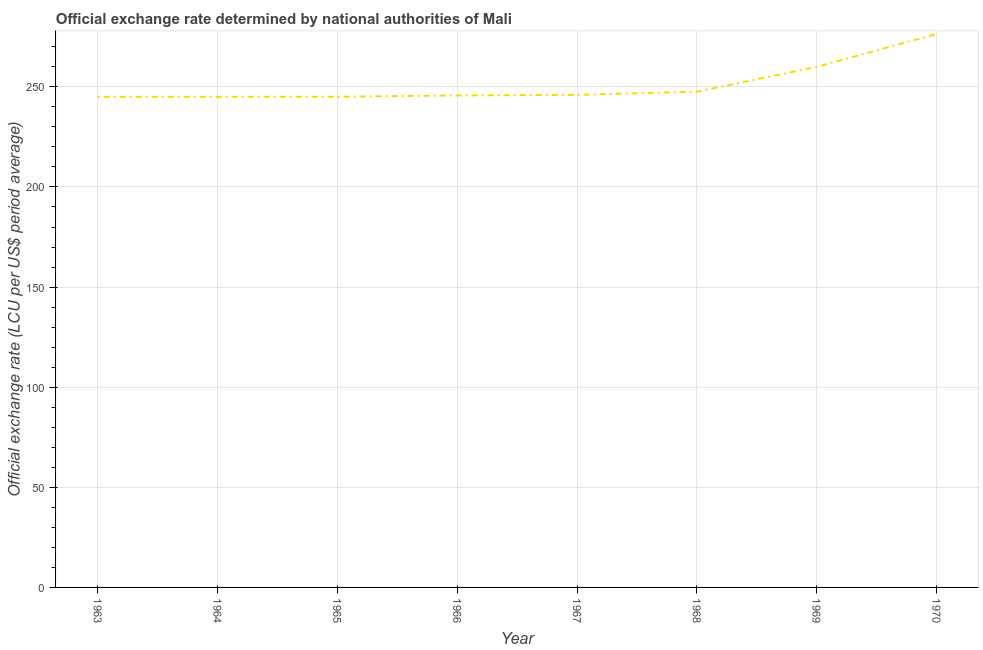What is the official exchange rate in 1969?
Your response must be concise. 259.96. Across all years, what is the maximum official exchange rate?
Your response must be concise. 276.4. Across all years, what is the minimum official exchange rate?
Offer a terse response. 245.02. In which year was the official exchange rate minimum?
Ensure brevity in your answer.  1963. What is the sum of the official exchange rate?
Your answer should be very brief. 2010.71. What is the difference between the official exchange rate in 1964 and 1968?
Provide a short and direct response. -2.54. What is the average official exchange rate per year?
Provide a succinct answer. 251.34. What is the median official exchange rate?
Your answer should be very brief. 245.84. In how many years, is the official exchange rate greater than 210 ?
Offer a very short reply. 8. Do a majority of the years between 1966 and 1963 (inclusive) have official exchange rate greater than 230 ?
Make the answer very short. Yes. What is the ratio of the official exchange rate in 1965 to that in 1968?
Offer a very short reply. 0.99. Is the difference between the official exchange rate in 1965 and 1968 greater than the difference between any two years?
Your response must be concise. No. What is the difference between the highest and the second highest official exchange rate?
Offer a very short reply. 16.44. Is the sum of the official exchange rate in 1963 and 1969 greater than the maximum official exchange rate across all years?
Give a very brief answer. Yes. What is the difference between the highest and the lowest official exchange rate?
Make the answer very short. 31.39. How many years are there in the graph?
Ensure brevity in your answer.  8. What is the difference between two consecutive major ticks on the Y-axis?
Keep it short and to the point. 50. Are the values on the major ticks of Y-axis written in scientific E-notation?
Provide a short and direct response. No. What is the title of the graph?
Ensure brevity in your answer.  Official exchange rate determined by national authorities of Mali. What is the label or title of the X-axis?
Your response must be concise. Year. What is the label or title of the Y-axis?
Your answer should be compact. Official exchange rate (LCU per US$ period average). What is the Official exchange rate (LCU per US$ period average) in 1963?
Keep it short and to the point. 245.02. What is the Official exchange rate (LCU per US$ period average) in 1964?
Provide a succinct answer. 245.03. What is the Official exchange rate (LCU per US$ period average) in 1965?
Offer a very short reply. 245.06. What is the Official exchange rate (LCU per US$ period average) of 1966?
Ensure brevity in your answer.  245.68. What is the Official exchange rate (LCU per US$ period average) in 1967?
Offer a very short reply. 246. What is the Official exchange rate (LCU per US$ period average) in 1968?
Make the answer very short. 247.56. What is the Official exchange rate (LCU per US$ period average) of 1969?
Provide a short and direct response. 259.96. What is the Official exchange rate (LCU per US$ period average) of 1970?
Offer a terse response. 276.4. What is the difference between the Official exchange rate (LCU per US$ period average) in 1963 and 1964?
Keep it short and to the point. -0.01. What is the difference between the Official exchange rate (LCU per US$ period average) in 1963 and 1965?
Your answer should be very brief. -0.04. What is the difference between the Official exchange rate (LCU per US$ period average) in 1963 and 1966?
Keep it short and to the point. -0.66. What is the difference between the Official exchange rate (LCU per US$ period average) in 1963 and 1967?
Ensure brevity in your answer.  -0.98. What is the difference between the Official exchange rate (LCU per US$ period average) in 1963 and 1968?
Your answer should be very brief. -2.55. What is the difference between the Official exchange rate (LCU per US$ period average) in 1963 and 1969?
Ensure brevity in your answer.  -14.94. What is the difference between the Official exchange rate (LCU per US$ period average) in 1963 and 1970?
Your answer should be very brief. -31.39. What is the difference between the Official exchange rate (LCU per US$ period average) in 1964 and 1965?
Provide a succinct answer. -0.03. What is the difference between the Official exchange rate (LCU per US$ period average) in 1964 and 1966?
Make the answer very short. -0.65. What is the difference between the Official exchange rate (LCU per US$ period average) in 1964 and 1967?
Provide a succinct answer. -0.97. What is the difference between the Official exchange rate (LCU per US$ period average) in 1964 and 1968?
Ensure brevity in your answer.  -2.54. What is the difference between the Official exchange rate (LCU per US$ period average) in 1964 and 1969?
Ensure brevity in your answer.  -14.93. What is the difference between the Official exchange rate (LCU per US$ period average) in 1964 and 1970?
Make the answer very short. -31.38. What is the difference between the Official exchange rate (LCU per US$ period average) in 1965 and 1966?
Your answer should be very brief. -0.62. What is the difference between the Official exchange rate (LCU per US$ period average) in 1965 and 1967?
Give a very brief answer. -0.94. What is the difference between the Official exchange rate (LCU per US$ period average) in 1965 and 1968?
Your answer should be compact. -2.5. What is the difference between the Official exchange rate (LCU per US$ period average) in 1965 and 1969?
Provide a succinct answer. -14.9. What is the difference between the Official exchange rate (LCU per US$ period average) in 1965 and 1970?
Make the answer very short. -31.34. What is the difference between the Official exchange rate (LCU per US$ period average) in 1966 and 1967?
Provide a short and direct response. -0.32. What is the difference between the Official exchange rate (LCU per US$ period average) in 1966 and 1968?
Provide a succinct answer. -1.89. What is the difference between the Official exchange rate (LCU per US$ period average) in 1966 and 1969?
Provide a succinct answer. -14.28. What is the difference between the Official exchange rate (LCU per US$ period average) in 1966 and 1970?
Ensure brevity in your answer.  -30.72. What is the difference between the Official exchange rate (LCU per US$ period average) in 1967 and 1968?
Provide a short and direct response. -1.56. What is the difference between the Official exchange rate (LCU per US$ period average) in 1967 and 1969?
Provide a short and direct response. -13.96. What is the difference between the Official exchange rate (LCU per US$ period average) in 1967 and 1970?
Your response must be concise. -30.4. What is the difference between the Official exchange rate (LCU per US$ period average) in 1968 and 1969?
Keep it short and to the point. -12.4. What is the difference between the Official exchange rate (LCU per US$ period average) in 1968 and 1970?
Ensure brevity in your answer.  -28.84. What is the difference between the Official exchange rate (LCU per US$ period average) in 1969 and 1970?
Keep it short and to the point. -16.44. What is the ratio of the Official exchange rate (LCU per US$ period average) in 1963 to that in 1966?
Ensure brevity in your answer.  1. What is the ratio of the Official exchange rate (LCU per US$ period average) in 1963 to that in 1969?
Provide a succinct answer. 0.94. What is the ratio of the Official exchange rate (LCU per US$ period average) in 1963 to that in 1970?
Make the answer very short. 0.89. What is the ratio of the Official exchange rate (LCU per US$ period average) in 1964 to that in 1967?
Your answer should be very brief. 1. What is the ratio of the Official exchange rate (LCU per US$ period average) in 1964 to that in 1969?
Offer a very short reply. 0.94. What is the ratio of the Official exchange rate (LCU per US$ period average) in 1964 to that in 1970?
Provide a succinct answer. 0.89. What is the ratio of the Official exchange rate (LCU per US$ period average) in 1965 to that in 1966?
Offer a terse response. 1. What is the ratio of the Official exchange rate (LCU per US$ period average) in 1965 to that in 1967?
Provide a short and direct response. 1. What is the ratio of the Official exchange rate (LCU per US$ period average) in 1965 to that in 1968?
Provide a short and direct response. 0.99. What is the ratio of the Official exchange rate (LCU per US$ period average) in 1965 to that in 1969?
Keep it short and to the point. 0.94. What is the ratio of the Official exchange rate (LCU per US$ period average) in 1965 to that in 1970?
Give a very brief answer. 0.89. What is the ratio of the Official exchange rate (LCU per US$ period average) in 1966 to that in 1968?
Your answer should be compact. 0.99. What is the ratio of the Official exchange rate (LCU per US$ period average) in 1966 to that in 1969?
Your response must be concise. 0.94. What is the ratio of the Official exchange rate (LCU per US$ period average) in 1966 to that in 1970?
Your answer should be compact. 0.89. What is the ratio of the Official exchange rate (LCU per US$ period average) in 1967 to that in 1968?
Give a very brief answer. 0.99. What is the ratio of the Official exchange rate (LCU per US$ period average) in 1967 to that in 1969?
Provide a short and direct response. 0.95. What is the ratio of the Official exchange rate (LCU per US$ period average) in 1967 to that in 1970?
Provide a succinct answer. 0.89. What is the ratio of the Official exchange rate (LCU per US$ period average) in 1968 to that in 1970?
Make the answer very short. 0.9. What is the ratio of the Official exchange rate (LCU per US$ period average) in 1969 to that in 1970?
Provide a succinct answer. 0.94. 